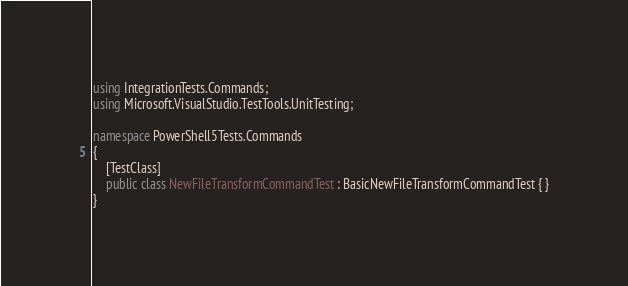Convert code to text. <code><loc_0><loc_0><loc_500><loc_500><_C#_>using IntegrationTests.Commands;
using Microsoft.VisualStudio.TestTools.UnitTesting;

namespace PowerShell5Tests.Commands
{
	[TestClass]
	public class NewFileTransformCommandTest : BasicNewFileTransformCommandTest { }
}</code> 